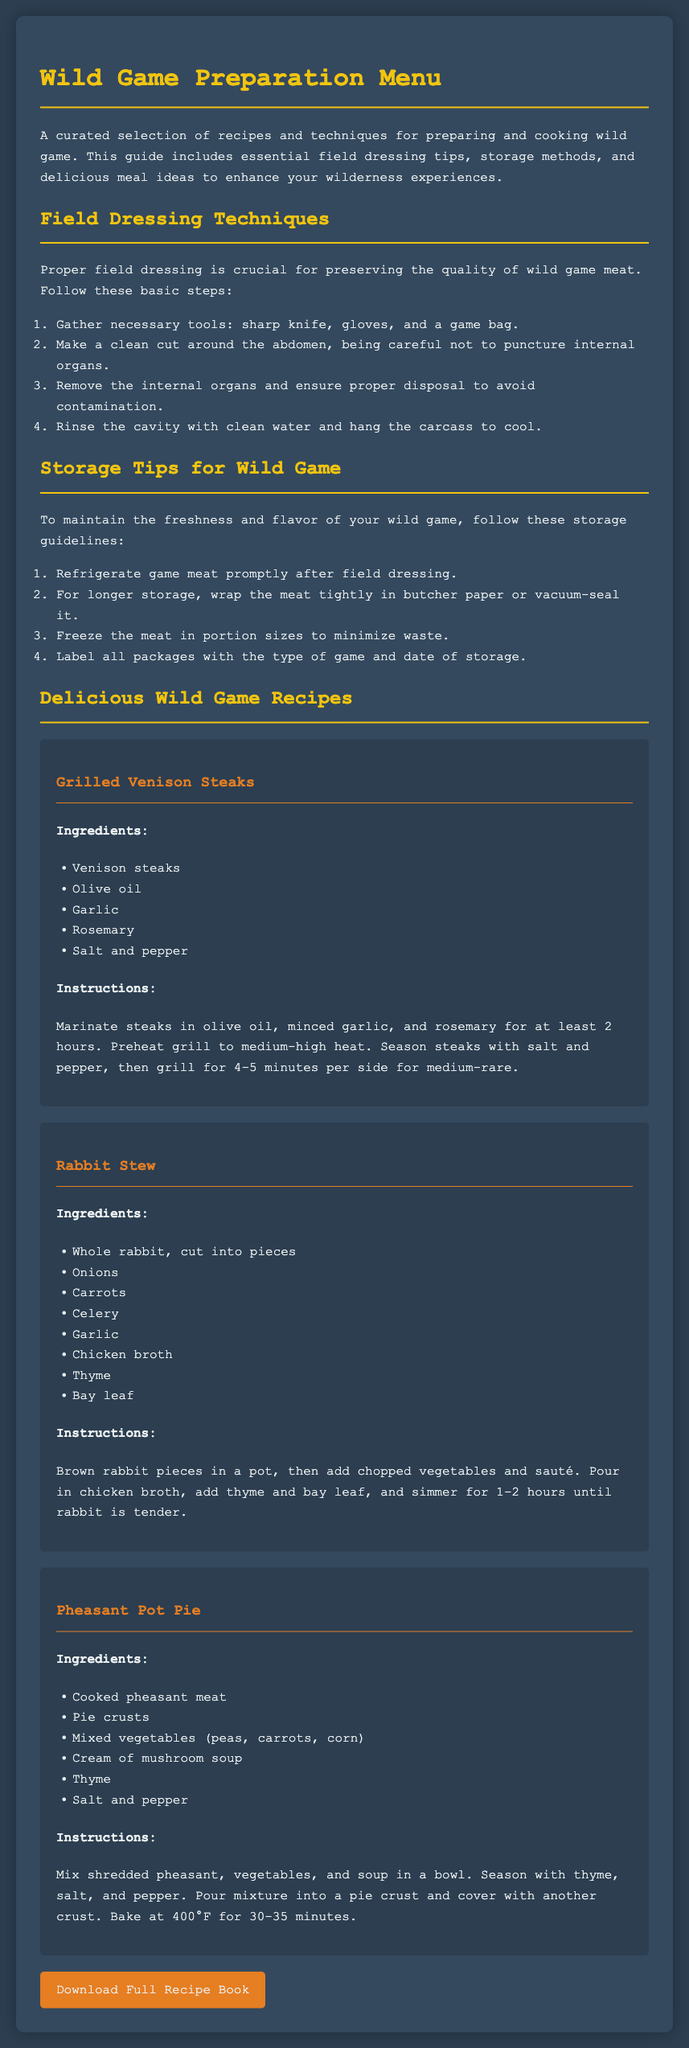what is the title of the document? The title of the document is prominently displayed at the top of the page.
Answer: Wild Game Preparation Menu how many field dressing steps are listed? The document contains an ordered list of steps for field dressing wild game.
Answer: 4 what temperature should the oven be set to for the Pheasant Pot Pie? The recipe specifies the temperature for baking the Pheasant Pot Pie.
Answer: 400°F which herb is mentioned in Grilled Venison Steaks? The recipe includes a specific herb used for marinating in the preparation of Grilled Venison Steaks.
Answer: Rosemary what is the main protein used in Rabbit Stew? The main protein of the dish is highlighted in the recipe.
Answer: Rabbit how long should the rabbit simmer in the stew? The document states the cooking duration for the stew.
Answer: 1-2 hours which ingredient is commonly found in the storage tips? The storage tips suggest a common method for preserving wild game meat.
Answer: Butcher paper which other wild game is mentioned aside from deer? The document lists various game meats included in the recipes.
Answer: Pheasant 